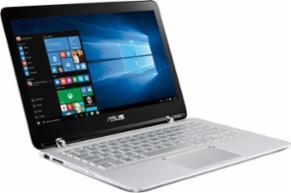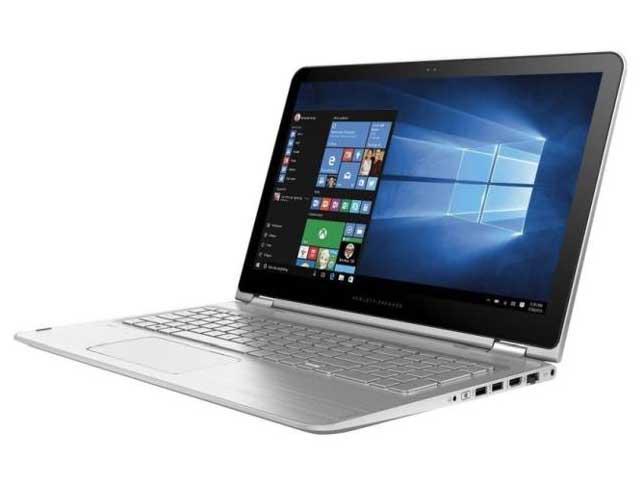The first image is the image on the left, the second image is the image on the right. Assess this claim about the two images: "All laptops have the screen part attached to the keyboard base, and no laptop is displayed head-on.". Correct or not? Answer yes or no. Yes. The first image is the image on the left, the second image is the image on the right. For the images shown, is this caption "The computer in the image on the left has a black casing." true? Answer yes or no. No. 